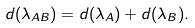<formula> <loc_0><loc_0><loc_500><loc_500>d ( \lambda _ { A B } ) = d ( \lambda _ { A } ) + d ( \lambda _ { B } ) .</formula> 